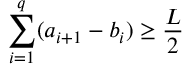Convert formula to latex. <formula><loc_0><loc_0><loc_500><loc_500>\sum _ { i = 1 } ^ { q } ( a _ { i + 1 } - b _ { i } ) \geq \frac { L } { 2 }</formula> 